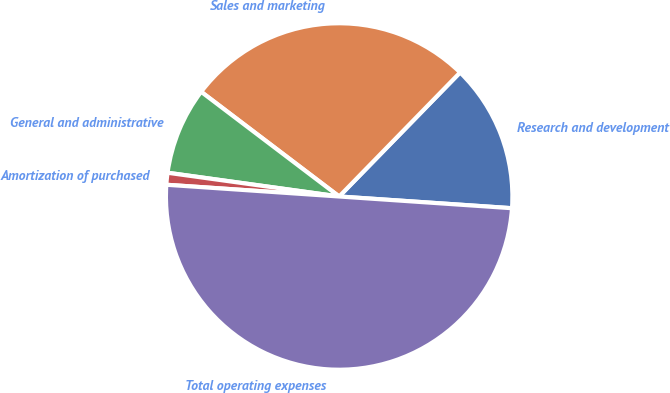Convert chart. <chart><loc_0><loc_0><loc_500><loc_500><pie_chart><fcel>Research and development<fcel>Sales and marketing<fcel>General and administrative<fcel>Amortization of purchased<fcel>Total operating expenses<nl><fcel>13.78%<fcel>26.97%<fcel>8.14%<fcel>1.11%<fcel>50.0%<nl></chart> 